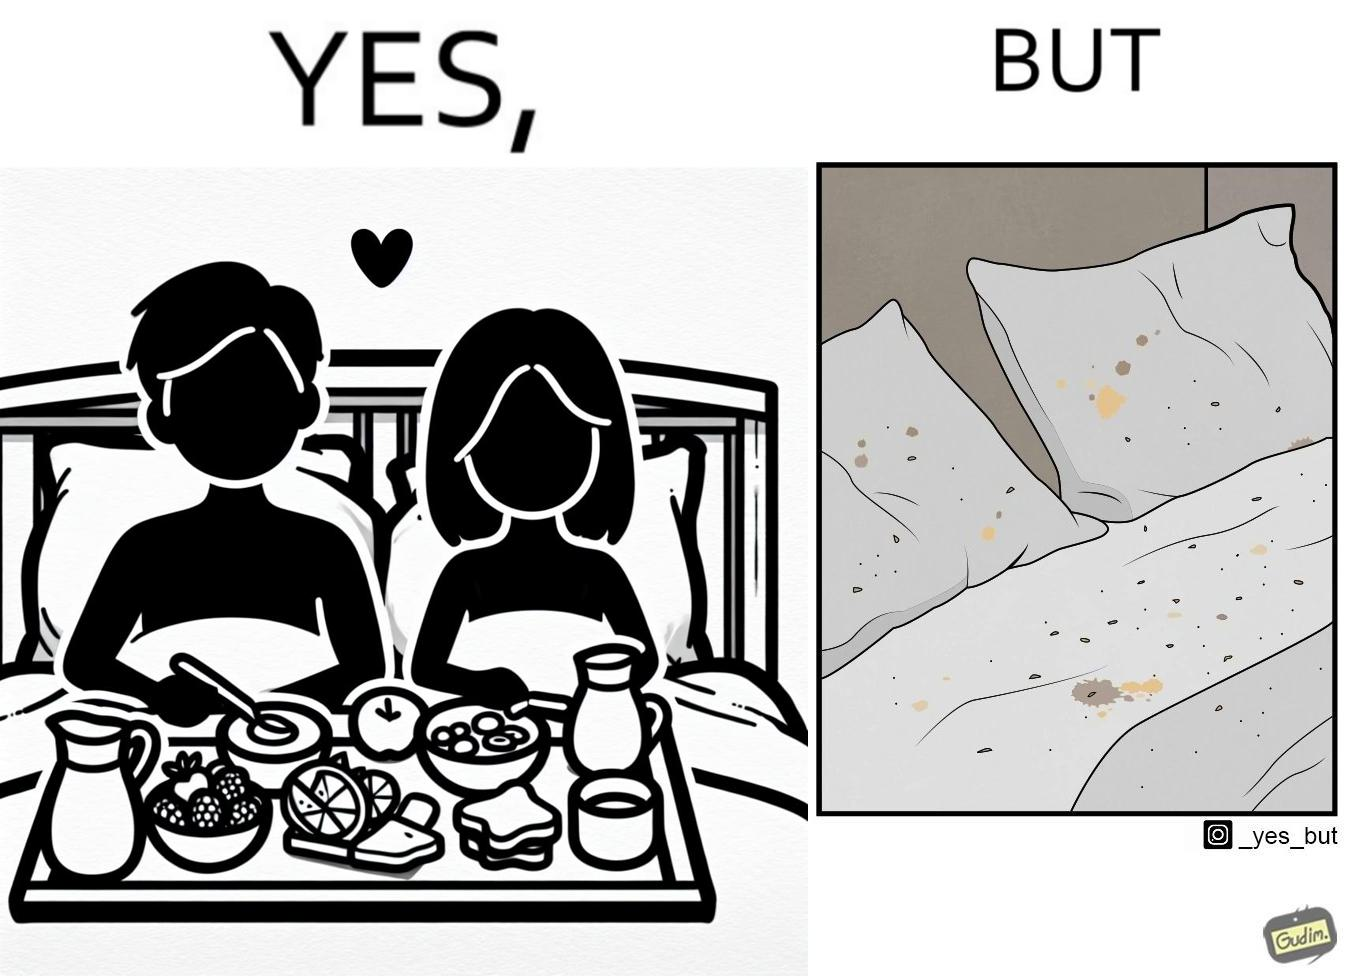Compare the left and right sides of this image. In the left part of the image: Breakfast on bed In the right part of the image: Food crumbs on bed 